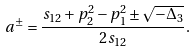<formula> <loc_0><loc_0><loc_500><loc_500>a ^ { \pm } = \frac { s _ { 1 2 } + p _ { 2 } ^ { 2 } - p _ { 1 } ^ { 2 } \pm \sqrt { - \Delta _ { 3 } } } { 2 s _ { 1 2 } } .</formula> 